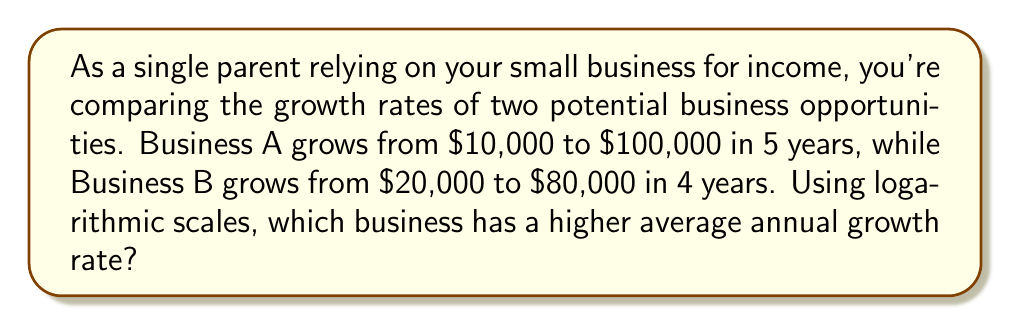What is the answer to this math problem? To compare growth rates using logarithmic scales, we'll use the formula for compound annual growth rate (CAGR):

$$ CAGR = \left(\frac{Ending Value}{Beginning Value}\right)^{\frac{1}{Number of Years}} - 1 $$

For Business A:
$$ CAGR_A = \left(\frac{100,000}{10,000}\right)^{\frac{1}{5}} - 1 $$

For Business B:
$$ CAGR_B = \left(\frac{80,000}{20,000}\right)^{\frac{1}{4}} - 1 $$

To simplify calculations, we can use logarithms:

$$ CAGR = e^{\frac{\ln(Ending Value) - \ln(Beginning Value)}{Number of Years}} - 1 $$

For Business A:
$$ CAGR_A = e^{\frac{\ln(100,000) - \ln(10,000)}{5}} - 1 $$
$$ = e^{\frac{11.51 - 9.21}{5}} - 1 $$
$$ = e^{0.46} - 1 $$
$$ \approx 0.5842 \text{ or } 58.42\% $$

For Business B:
$$ CAGR_B = e^{\frac{\ln(80,000) - \ln(20,000)}{4}} - 1 $$
$$ = e^{\frac{11.29 - 9.90}{4}} - 1 $$
$$ = e^{0.3475} - 1 $$
$$ \approx 0.4155 \text{ or } 41.55\% $$

Business A has a higher average annual growth rate of 58.42% compared to Business B's 41.55%.
Answer: Business A (58.42% growth rate) 